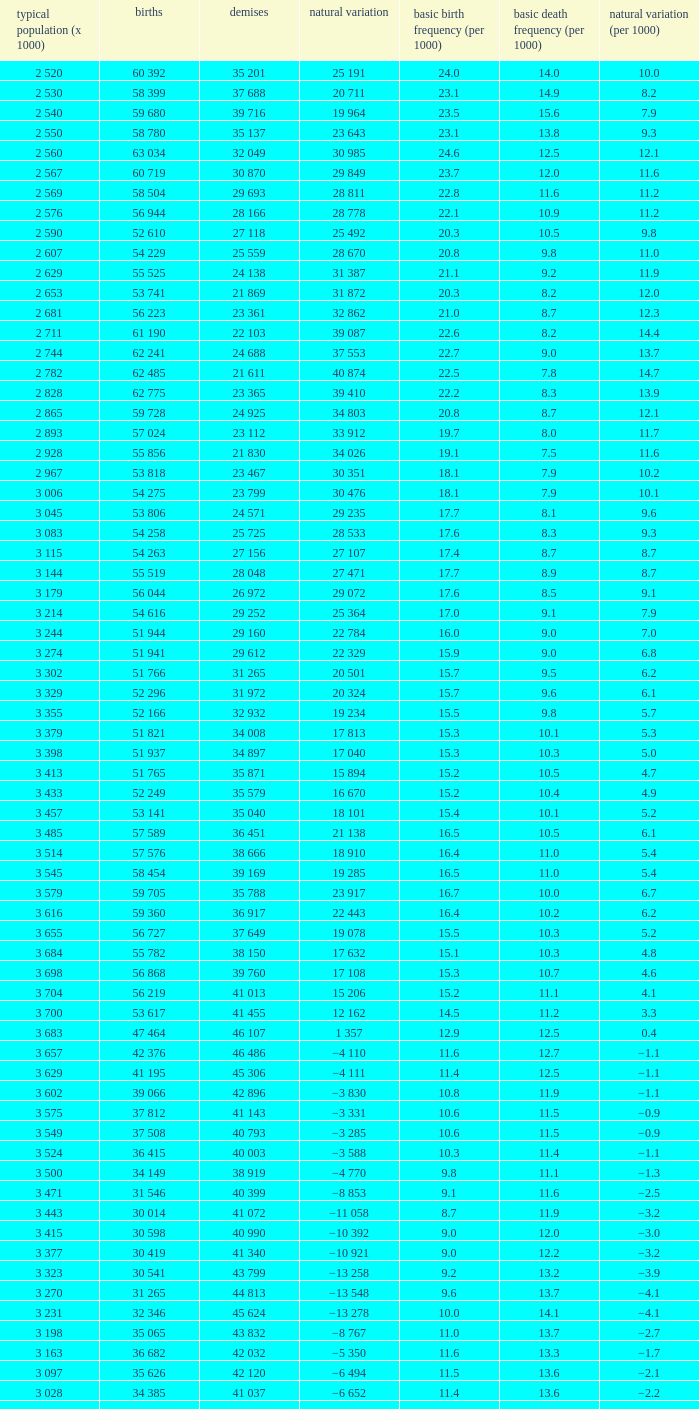Which Average population (x 1000) has a Crude death rate (per 1000) smaller than 10.9, and a Crude birth rate (per 1000) smaller than 19.7, and a Natural change (per 1000) of 8.7, and Live births of 54 263? 3 115. I'm looking to parse the entire table for insights. Could you assist me with that? {'header': ['typical population (x 1000)', 'births', 'demises', 'natural variation', 'basic birth frequency (per 1000)', 'basic death frequency (per 1000)', 'natural variation (per 1000)'], 'rows': [['2 520', '60 392', '35 201', '25 191', '24.0', '14.0', '10.0'], ['2 530', '58 399', '37 688', '20 711', '23.1', '14.9', '8.2'], ['2 540', '59 680', '39 716', '19 964', '23.5', '15.6', '7.9'], ['2 550', '58 780', '35 137', '23 643', '23.1', '13.8', '9.3'], ['2 560', '63 034', '32 049', '30 985', '24.6', '12.5', '12.1'], ['2 567', '60 719', '30 870', '29 849', '23.7', '12.0', '11.6'], ['2 569', '58 504', '29 693', '28 811', '22.8', '11.6', '11.2'], ['2 576', '56 944', '28 166', '28 778', '22.1', '10.9', '11.2'], ['2 590', '52 610', '27 118', '25 492', '20.3', '10.5', '9.8'], ['2 607', '54 229', '25 559', '28 670', '20.8', '9.8', '11.0'], ['2 629', '55 525', '24 138', '31 387', '21.1', '9.2', '11.9'], ['2 653', '53 741', '21 869', '31 872', '20.3', '8.2', '12.0'], ['2 681', '56 223', '23 361', '32 862', '21.0', '8.7', '12.3'], ['2 711', '61 190', '22 103', '39 087', '22.6', '8.2', '14.4'], ['2 744', '62 241', '24 688', '37 553', '22.7', '9.0', '13.7'], ['2 782', '62 485', '21 611', '40 874', '22.5', '7.8', '14.7'], ['2 828', '62 775', '23 365', '39 410', '22.2', '8.3', '13.9'], ['2 865', '59 728', '24 925', '34 803', '20.8', '8.7', '12.1'], ['2 893', '57 024', '23 112', '33 912', '19.7', '8.0', '11.7'], ['2 928', '55 856', '21 830', '34 026', '19.1', '7.5', '11.6'], ['2 967', '53 818', '23 467', '30 351', '18.1', '7.9', '10.2'], ['3 006', '54 275', '23 799', '30 476', '18.1', '7.9', '10.1'], ['3 045', '53 806', '24 571', '29 235', '17.7', '8.1', '9.6'], ['3 083', '54 258', '25 725', '28 533', '17.6', '8.3', '9.3'], ['3 115', '54 263', '27 156', '27 107', '17.4', '8.7', '8.7'], ['3 144', '55 519', '28 048', '27 471', '17.7', '8.9', '8.7'], ['3 179', '56 044', '26 972', '29 072', '17.6', '8.5', '9.1'], ['3 214', '54 616', '29 252', '25 364', '17.0', '9.1', '7.9'], ['3 244', '51 944', '29 160', '22 784', '16.0', '9.0', '7.0'], ['3 274', '51 941', '29 612', '22 329', '15.9', '9.0', '6.8'], ['3 302', '51 766', '31 265', '20 501', '15.7', '9.5', '6.2'], ['3 329', '52 296', '31 972', '20 324', '15.7', '9.6', '6.1'], ['3 355', '52 166', '32 932', '19 234', '15.5', '9.8', '5.7'], ['3 379', '51 821', '34 008', '17 813', '15.3', '10.1', '5.3'], ['3 398', '51 937', '34 897', '17 040', '15.3', '10.3', '5.0'], ['3 413', '51 765', '35 871', '15 894', '15.2', '10.5', '4.7'], ['3 433', '52 249', '35 579', '16 670', '15.2', '10.4', '4.9'], ['3 457', '53 141', '35 040', '18 101', '15.4', '10.1', '5.2'], ['3 485', '57 589', '36 451', '21 138', '16.5', '10.5', '6.1'], ['3 514', '57 576', '38 666', '18 910', '16.4', '11.0', '5.4'], ['3 545', '58 454', '39 169', '19 285', '16.5', '11.0', '5.4'], ['3 579', '59 705', '35 788', '23 917', '16.7', '10.0', '6.7'], ['3 616', '59 360', '36 917', '22 443', '16.4', '10.2', '6.2'], ['3 655', '56 727', '37 649', '19 078', '15.5', '10.3', '5.2'], ['3 684', '55 782', '38 150', '17 632', '15.1', '10.3', '4.8'], ['3 698', '56 868', '39 760', '17 108', '15.3', '10.7', '4.6'], ['3 704', '56 219', '41 013', '15 206', '15.2', '11.1', '4.1'], ['3 700', '53 617', '41 455', '12 162', '14.5', '11.2', '3.3'], ['3 683', '47 464', '46 107', '1 357', '12.9', '12.5', '0.4'], ['3 657', '42 376', '46 486', '−4 110', '11.6', '12.7', '−1.1'], ['3 629', '41 195', '45 306', '−4 111', '11.4', '12.5', '−1.1'], ['3 602', '39 066', '42 896', '−3 830', '10.8', '11.9', '−1.1'], ['3 575', '37 812', '41 143', '−3 331', '10.6', '11.5', '−0.9'], ['3 549', '37 508', '40 793', '−3 285', '10.6', '11.5', '−0.9'], ['3 524', '36 415', '40 003', '−3 588', '10.3', '11.4', '−1.1'], ['3 500', '34 149', '38 919', '−4 770', '9.8', '11.1', '−1.3'], ['3 471', '31 546', '40 399', '−8 853', '9.1', '11.6', '−2.5'], ['3 443', '30 014', '41 072', '−11 058', '8.7', '11.9', '−3.2'], ['3 415', '30 598', '40 990', '−10 392', '9.0', '12.0', '−3.0'], ['3 377', '30 419', '41 340', '−10 921', '9.0', '12.2', '−3.2'], ['3 323', '30 541', '43 799', '−13 258', '9.2', '13.2', '−3.9'], ['3 270', '31 265', '44 813', '−13 548', '9.6', '13.7', '−4.1'], ['3 231', '32 346', '45 624', '−13 278', '10.0', '14.1', '−4.1'], ['3 198', '35 065', '43 832', '−8 767', '11.0', '13.7', '−2.7'], ['3 163', '36 682', '42 032', '−5 350', '11.6', '13.3', '−1.7'], ['3 097', '35 626', '42 120', '−6 494', '11.5', '13.6', '−2.1'], ['3 028', '34 385', '41 037', '−6 652', '11.4', '13.6', '−2.2'], ['2 988', '30 459', '40 938', '−10 479', '10.2', '13.7', '−3.5']]} 